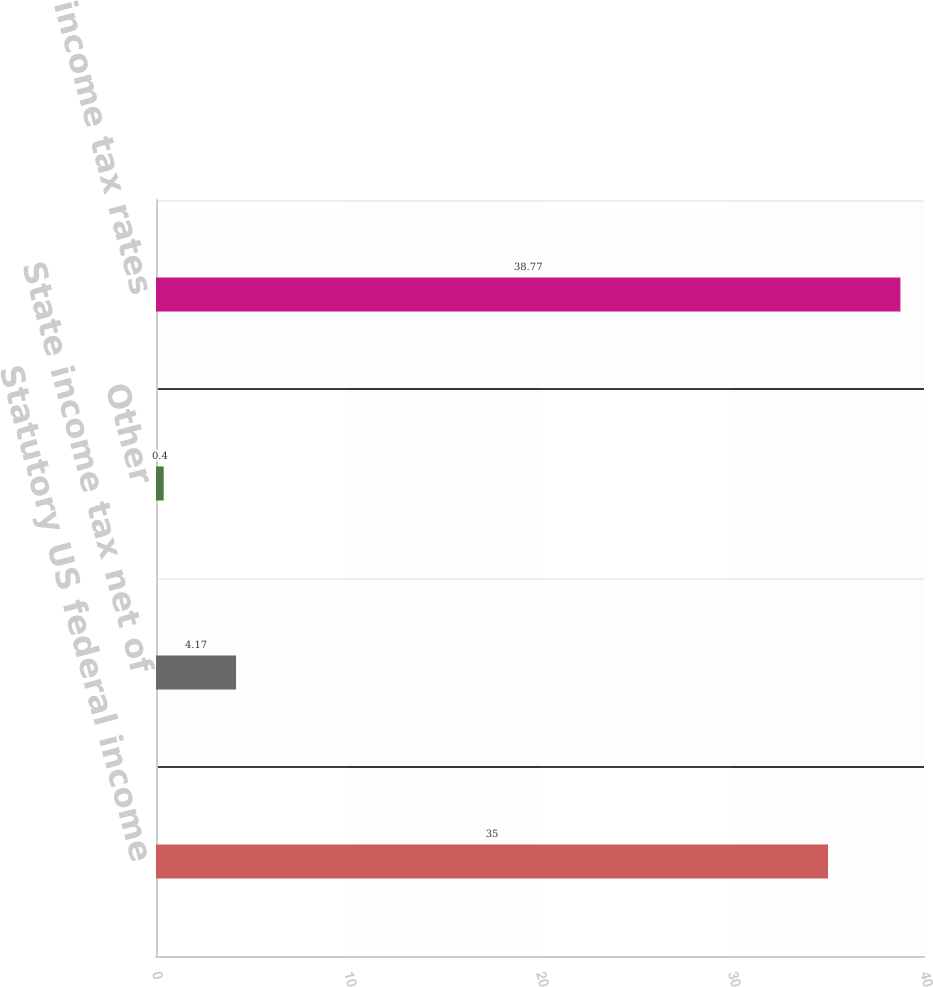Convert chart to OTSL. <chart><loc_0><loc_0><loc_500><loc_500><bar_chart><fcel>Statutory US federal income<fcel>State income tax net of<fcel>Other<fcel>Effective income tax rates<nl><fcel>35<fcel>4.17<fcel>0.4<fcel>38.77<nl></chart> 